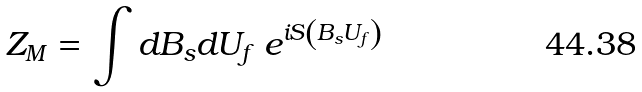<formula> <loc_0><loc_0><loc_500><loc_500>Z _ { M } = \int d B _ { s } d U _ { f } \ e ^ { i S \left ( B _ { s } U _ { f } \right ) }</formula> 